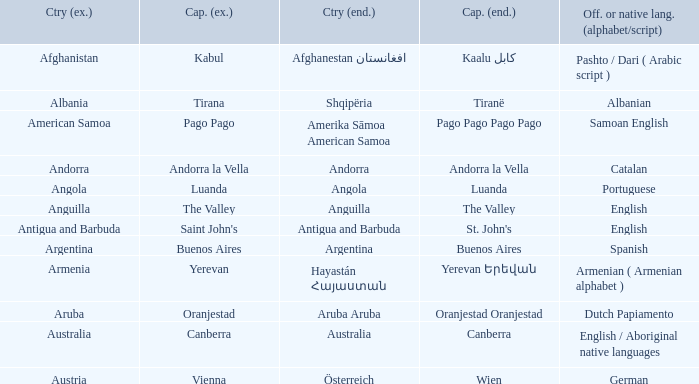What is the English name of the country whose official native language is Dutch Papiamento? Aruba. 